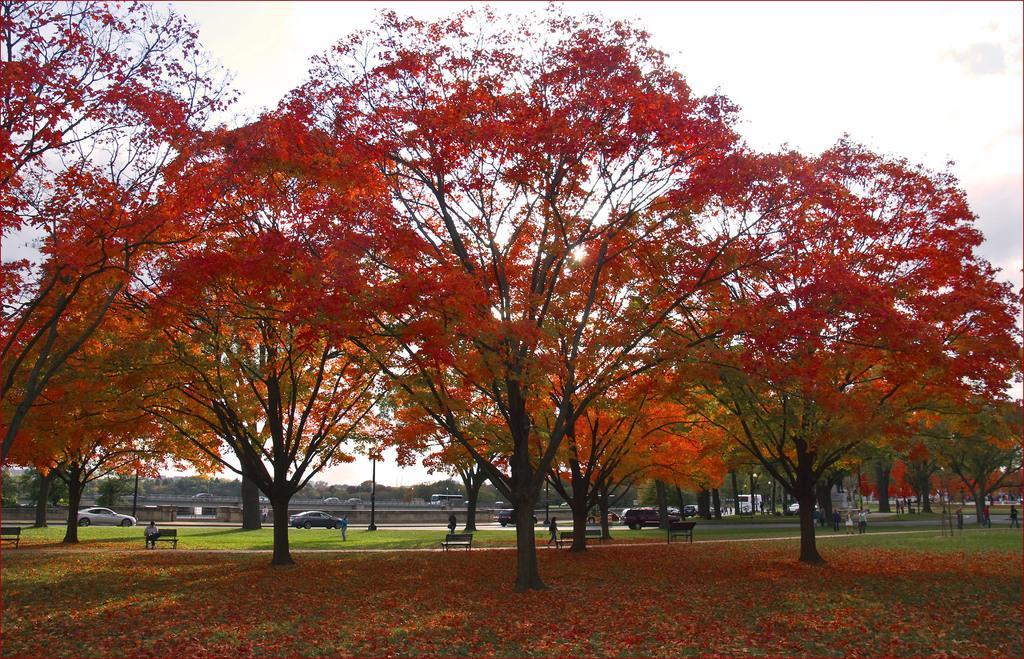How would you summarize this image in a sentence or two? In this image we can see many trees. In the back there are many vehicles. Also there are many people. There are benches. In the background there is sky. 